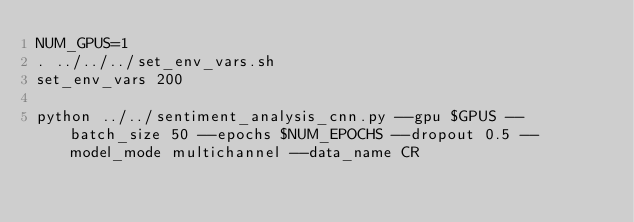<code> <loc_0><loc_0><loc_500><loc_500><_Bash_>NUM_GPUS=1
. ../../../set_env_vars.sh
set_env_vars 200

python ../../sentiment_analysis_cnn.py --gpu $GPUS --batch_size 50 --epochs $NUM_EPOCHS --dropout 0.5 --model_mode multichannel --data_name CR
</code> 